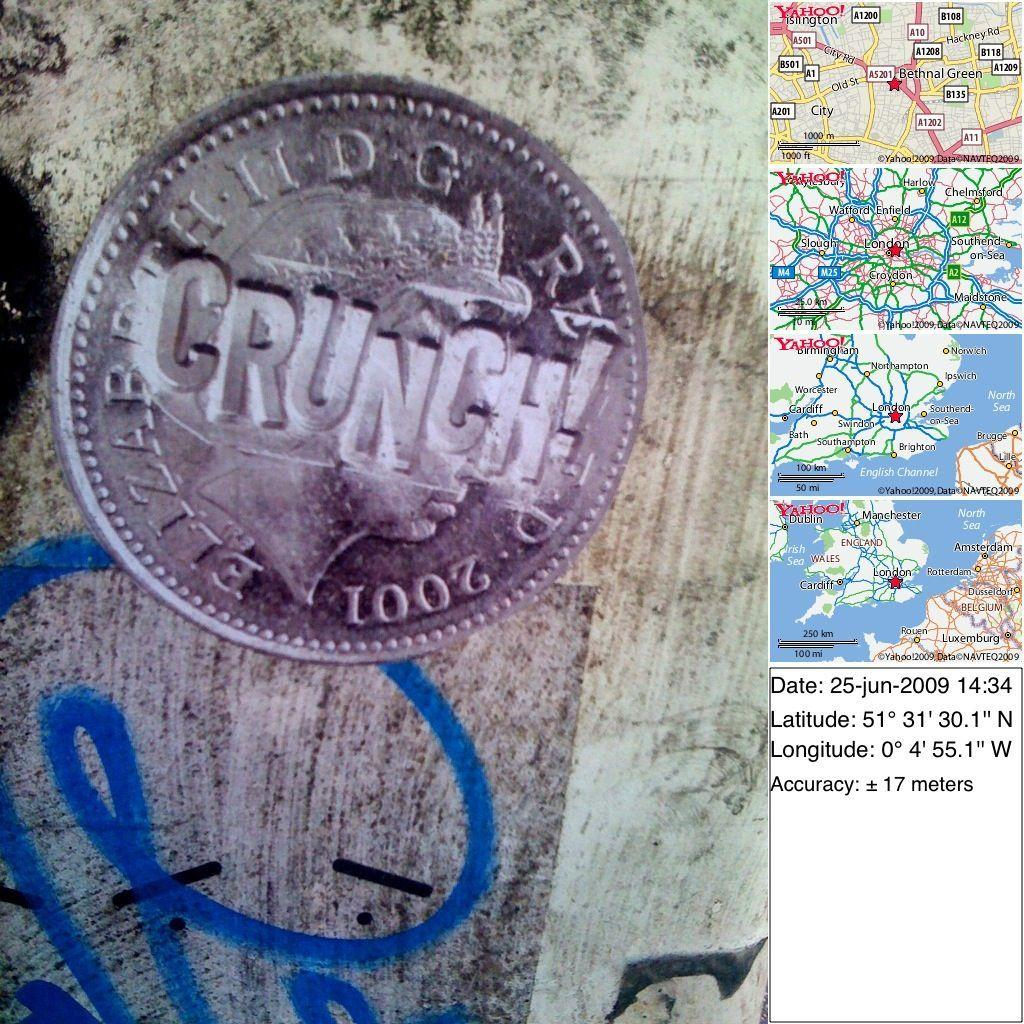<image>
Relay a brief, clear account of the picture shown. Several small maps and a coin that says Crunch. 